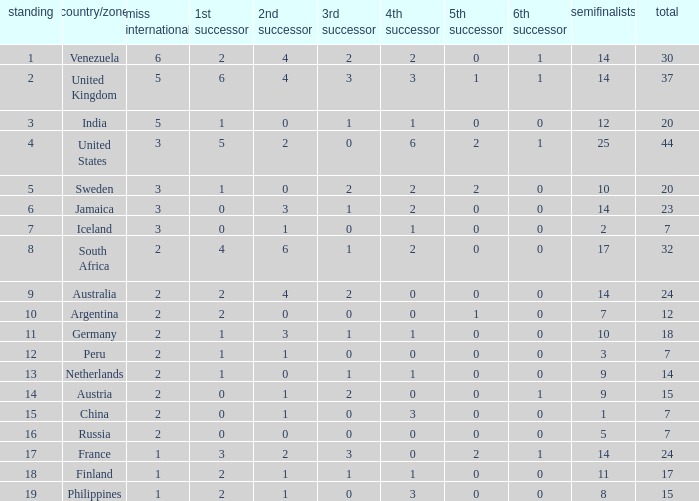What is the United States rank? 1.0. 